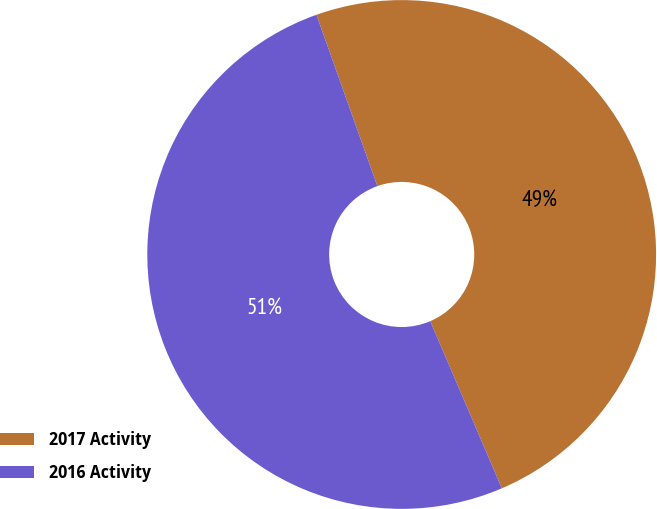Convert chart. <chart><loc_0><loc_0><loc_500><loc_500><pie_chart><fcel>2017 Activity<fcel>2016 Activity<nl><fcel>49.0%<fcel>51.0%<nl></chart> 